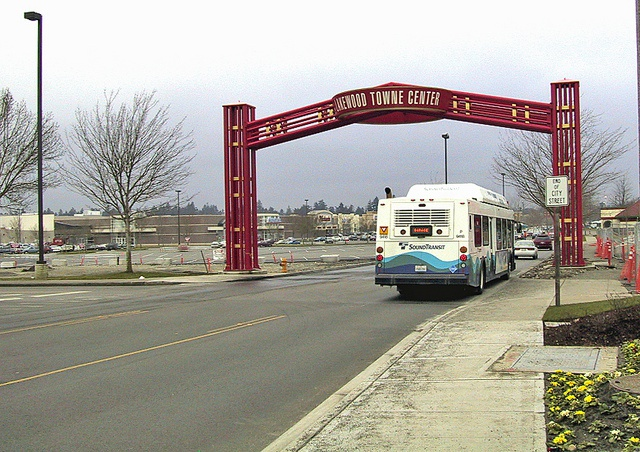Describe the objects in this image and their specific colors. I can see bus in white, ivory, black, gray, and darkgray tones, car in white, ivory, darkgray, black, and beige tones, car in white, black, gray, darkgray, and lightgray tones, car in white, black, gray, darkgray, and maroon tones, and car in white, gray, darkgray, black, and olive tones in this image. 